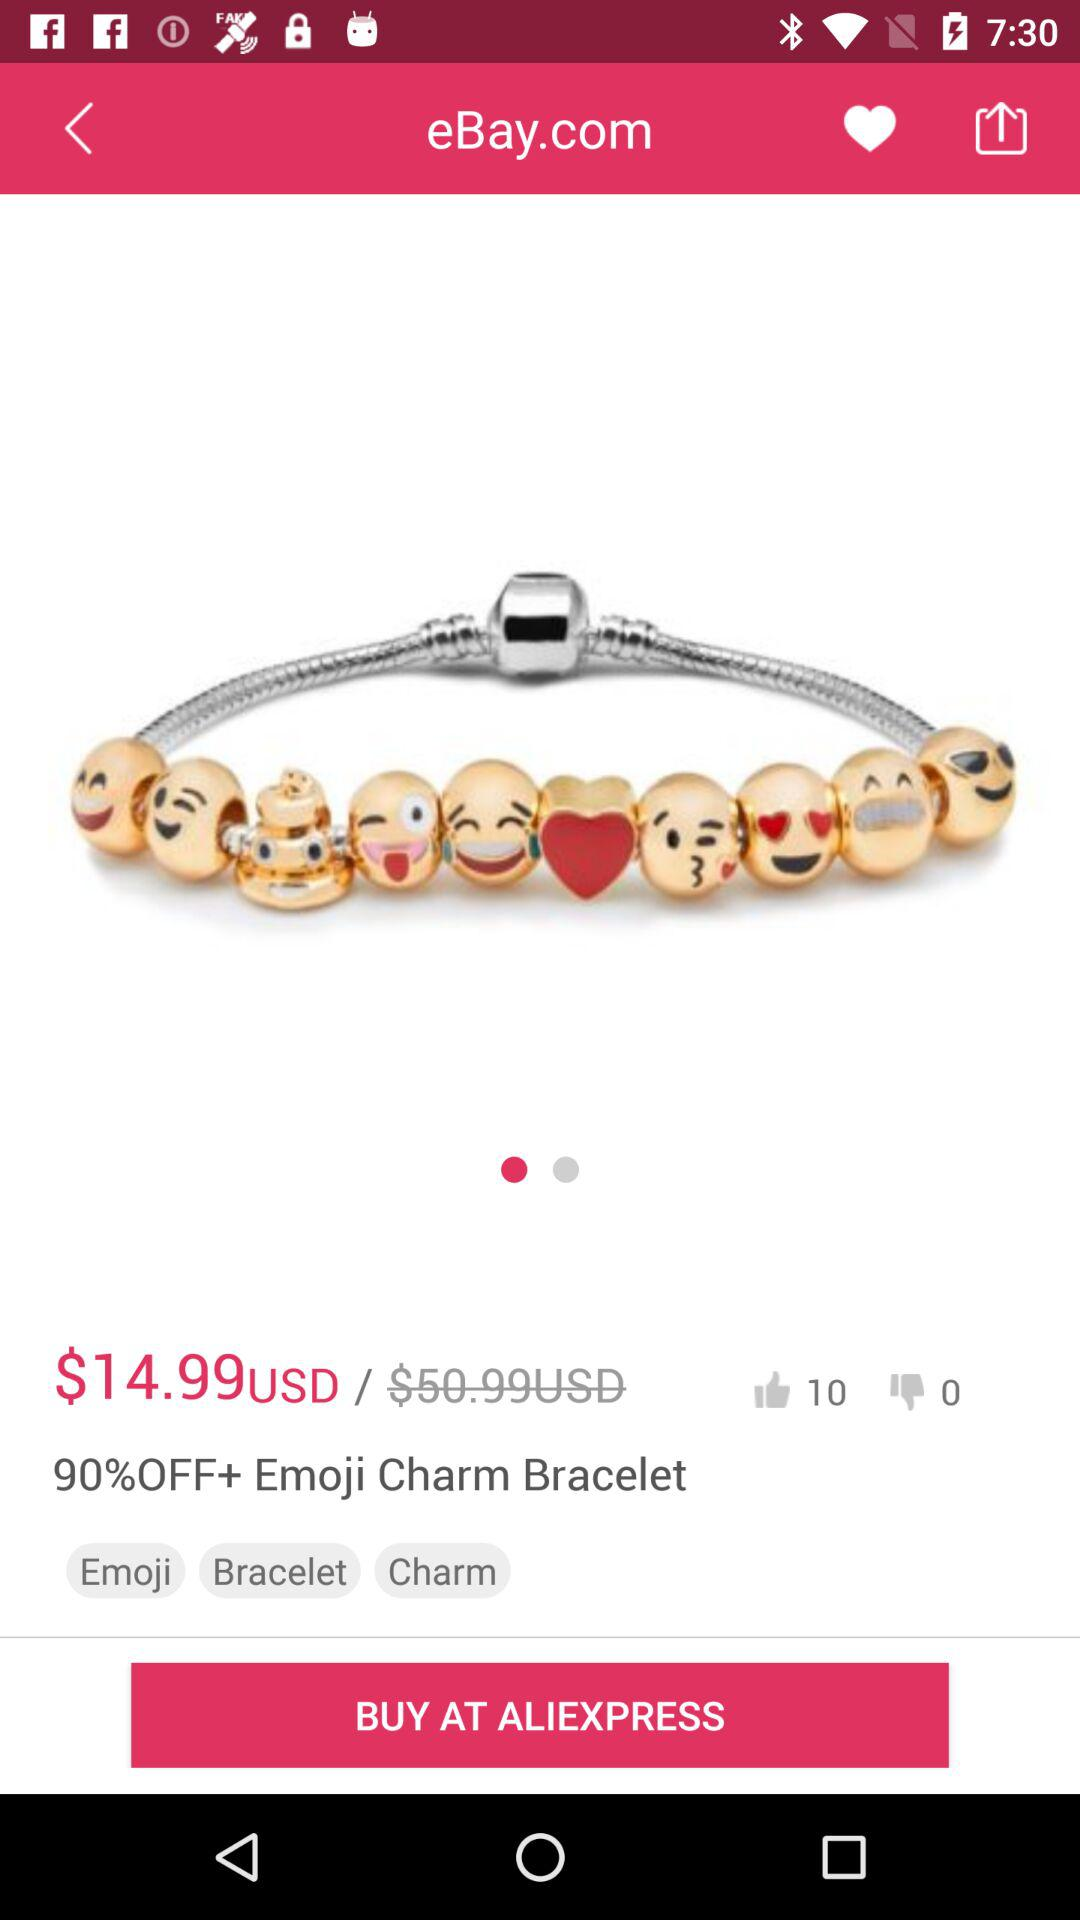What is the currency of the price? The currency of the price is the dollar. 